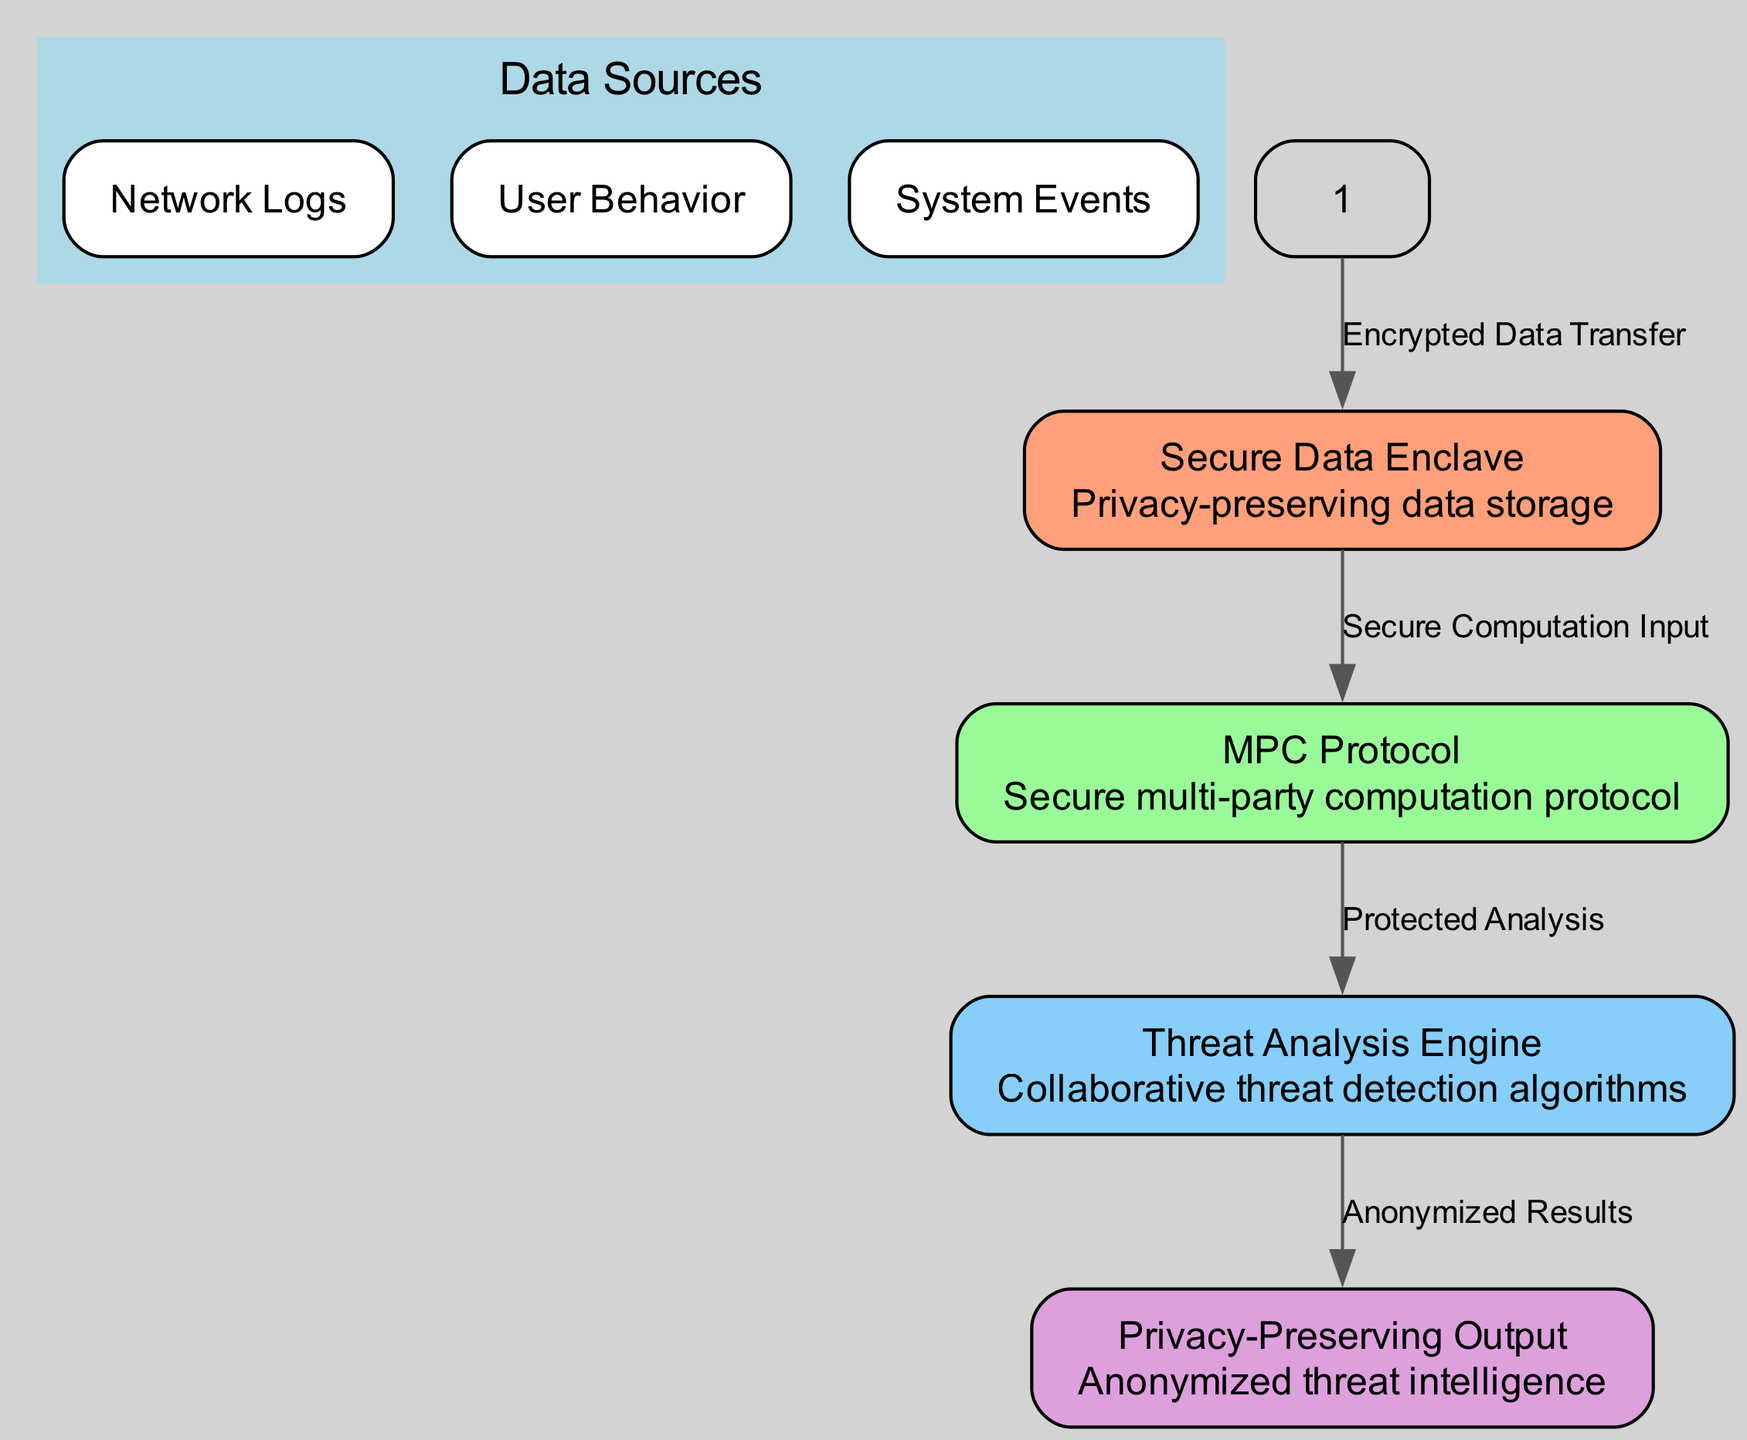What are the child nodes of Data Sources? The Data Sources node has three child nodes: Network Logs, User Behavior, and System Events. These are explicitly listed under the Data Sources node in the diagram.
Answer: Network Logs, User Behavior, System Events What is the label of the node that stores data? The node responsible for privacy-preserving data storage is labeled "Secure Data Enclave". This is directly indicated in the diagram under the corresponding node.
Answer: Secure Data Enclave How many nodes are in the diagram? By counting each distinct node shown in the diagram, there are a total of five nodes. This includes both the parent and child nodes.
Answer: 5 What type of protocol is represented in the diagram? The protocol indicated in the diagram is a "Secure multi-party computation protocol", as described in the node labeled "MPC Protocol".
Answer: Secure multi-party computation protocol What is the output of the Threat Analysis Engine node? The output produced by the Threat Analysis Engine is described as "Anonymized Results". This is stated clearly in the edge leading out from the Threat Analysis Engine node.
Answer: Anonymized Results What does the edge from Secure Data Enclave to MPC Protocol represent? The edge connecting Secure Data Enclave to MPC Protocol is labeled "Secure Computation Input". This indicates the function of data transfer between these two nodes.
Answer: Secure Computation Input Which node precedes the Privacy-Preserving Output node in the workflow? The node that comes before Privacy-Preserving Output in the workflow is Threat Analysis Engine, as shown in the directed flow of the diagram.
Answer: Threat Analysis Engine What types of analytics does the Threat Analysis Engine utilize? The Threat Analysis Engine uses "Collaborative threat detection algorithms", which is outlined in the description section of the corresponding node in the diagram.
Answer: Collaborative threat detection algorithms 